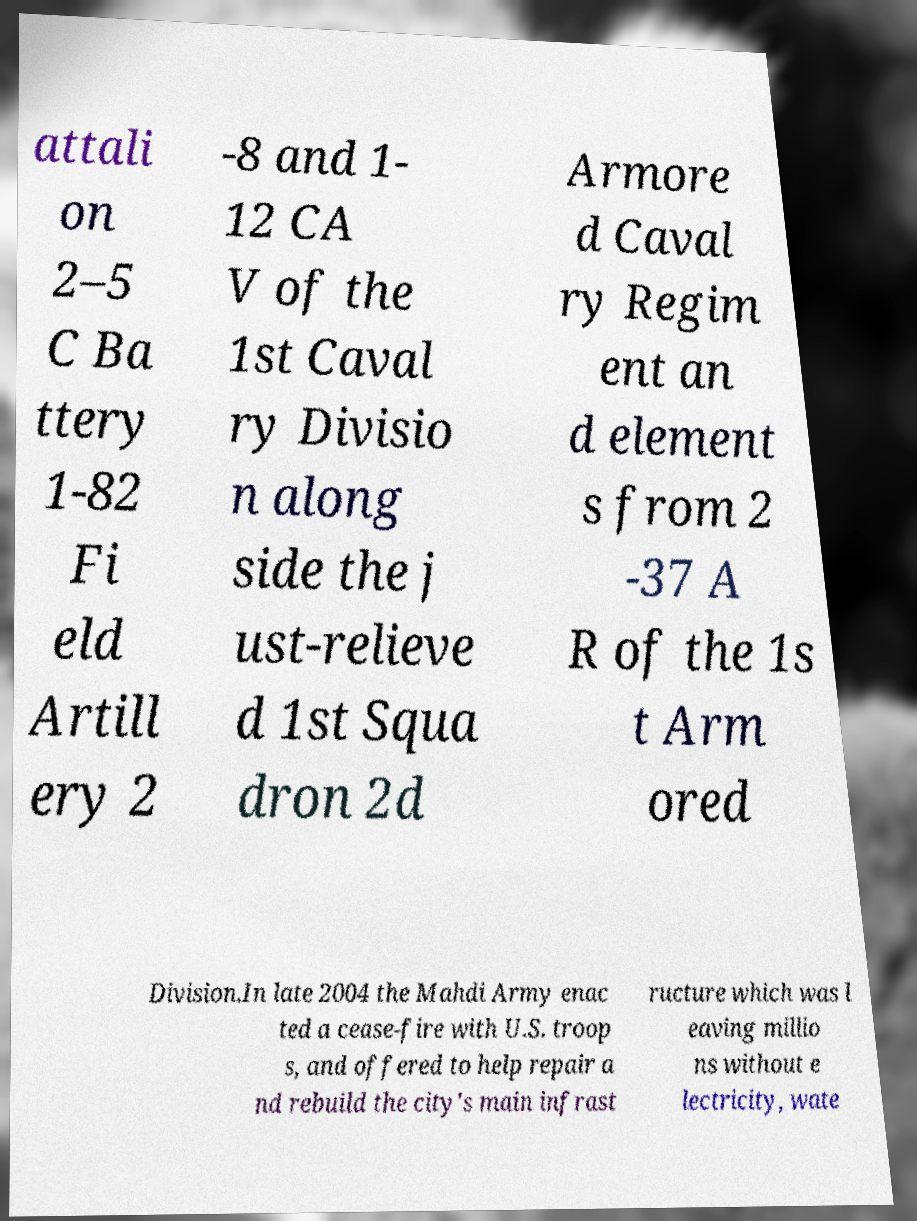Could you extract and type out the text from this image? attali on 2–5 C Ba ttery 1-82 Fi eld Artill ery 2 -8 and 1- 12 CA V of the 1st Caval ry Divisio n along side the j ust-relieve d 1st Squa dron 2d Armore d Caval ry Regim ent an d element s from 2 -37 A R of the 1s t Arm ored Division.In late 2004 the Mahdi Army enac ted a cease-fire with U.S. troop s, and offered to help repair a nd rebuild the city's main infrast ructure which was l eaving millio ns without e lectricity, wate 